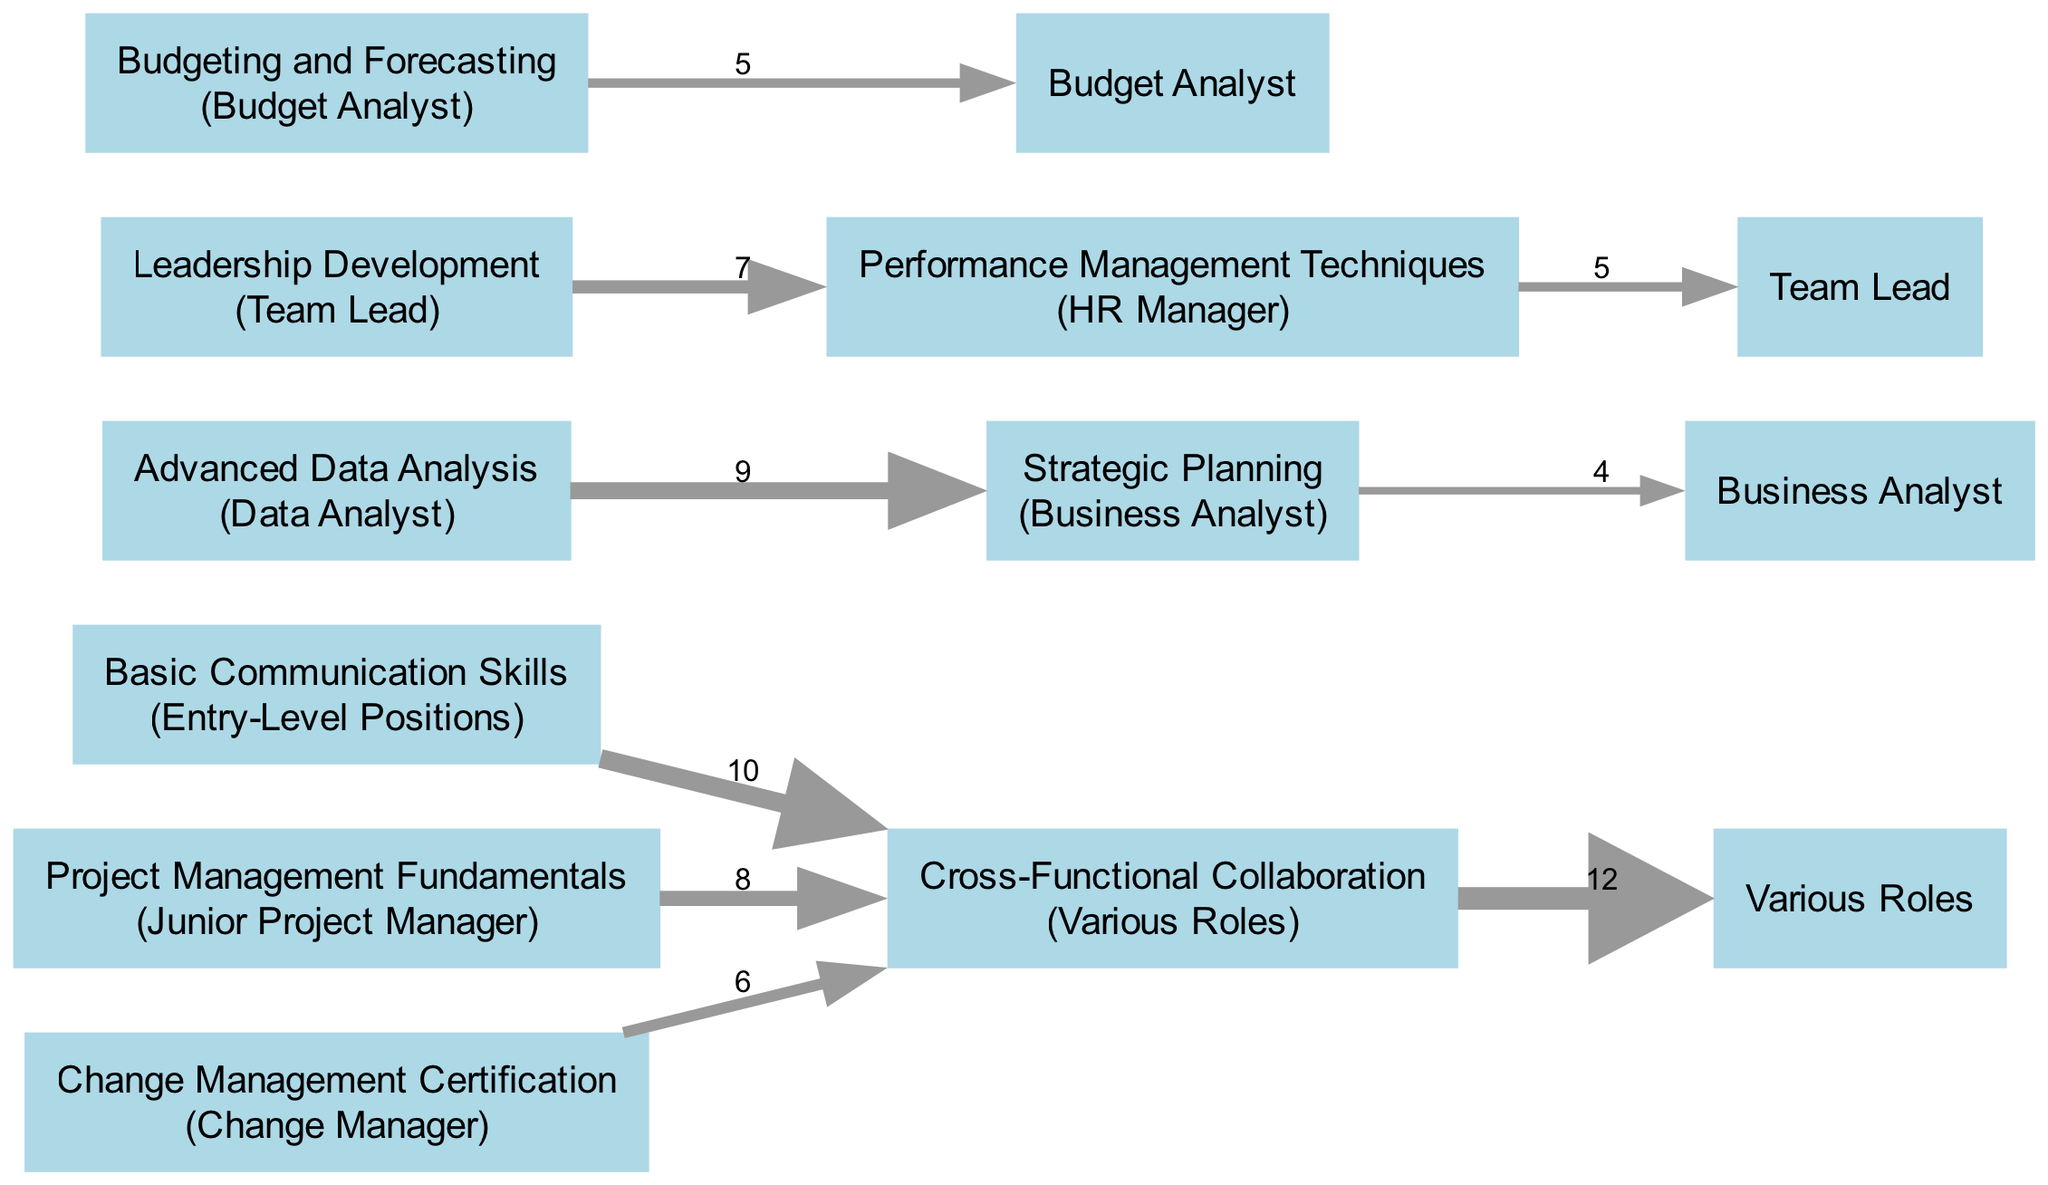What is the total number of training nodes in the diagram? By examining the nodes listed in the diagram, we count all the training-related nodes: Basic Communication Skills, Project Management Fundamentals, Advanced Data Analysis, Leadership Development, Change Management Certification, and Performance Management Techniques. This sums up to six training nodes.
Answer: 6 What is the value of the link from Advanced Data Analysis to Strategic Planning? The diagram shows a specific link from Advanced Data Analysis to Strategic Planning with a value of 9. This directly indicates the strength of that connection, which is given as 9.
Answer: 9 Which skill is connected to the highest value node? Looking across the links, the highest value connection is from Cross-Functional Collaboration to Various Roles, with a value of 12. This indicates that Many roles are influenced by skills related to Cross-Functional Collaboration.
Answer: Cross-Functional Collaboration How many nodes are linked to Leadership Development? Examining the links, Leadership Development connects with one node, which is Performance Management Techniques. Thus, it has a single outgoing connection.
Answer: 1 What do the values in the links represent? The values represent the strength or significance of the connection between the training programs and the skills they develop. Higher values indicate a stronger impact on the following skill or role.
Answer: Strength of connection Which training program leads to the role of HR Manager? The link shows that Performance Management Techniques influences the role of HR Manager. This indicates that skills learned in this training are essential for that position.
Answer: Performance Management Techniques What is the cumulative value of links from Basic Communication Skills? The direct link from Basic Communication Skills leads to Cross-Functional Collaboration with a value of 10. Since there are no other links originating from Basic Communication Skills, the cumulative value is simply that single link's value.
Answer: 10 Which training program primarily develops skills for a Budget Analyst? The diagram indicates that Budgeting and Forecasting is the training program that specifically leads to the role of Budget Analyst, showing a direct connection.
Answer: Budgeting and Forecasting How many skills originate from Project Management Fundamentals? Upon reviewing the diagram, Project Management Fundamentals links solely to Cross-Functional Collaboration, which signifies that it connects to one skill only.
Answer: 1 